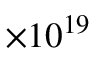<formula> <loc_0><loc_0><loc_500><loc_500>\times 1 0 ^ { 1 9 }</formula> 